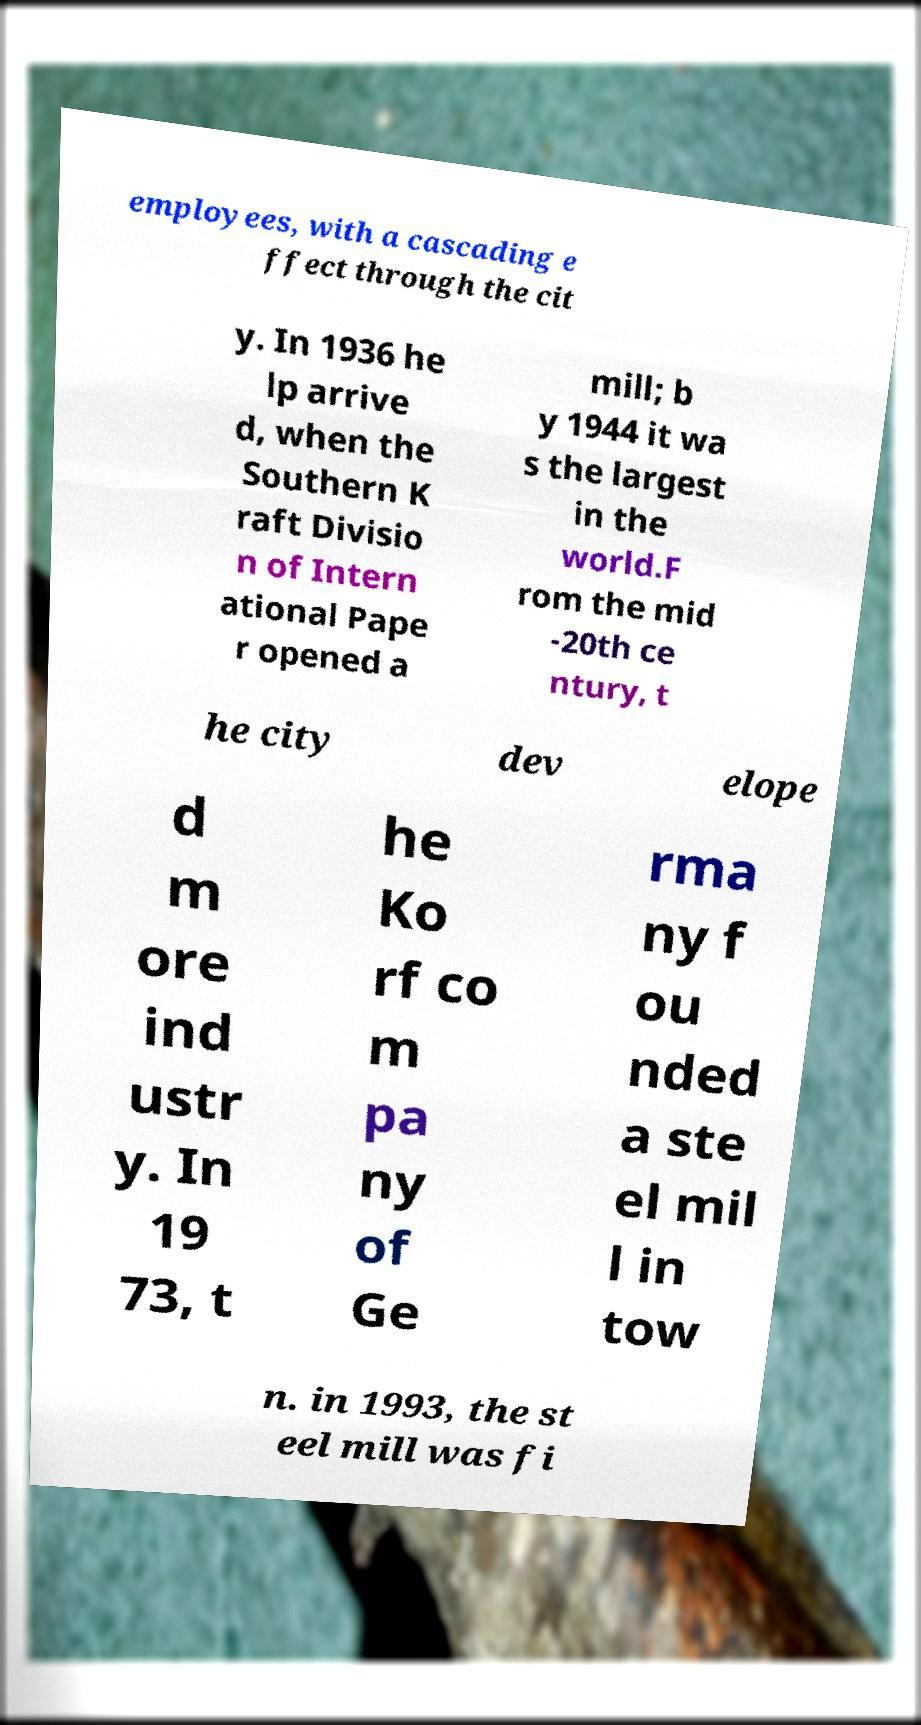Please identify and transcribe the text found in this image. employees, with a cascading e ffect through the cit y. In 1936 he lp arrive d, when the Southern K raft Divisio n of Intern ational Pape r opened a mill; b y 1944 it wa s the largest in the world.F rom the mid -20th ce ntury, t he city dev elope d m ore ind ustr y. In 19 73, t he Ko rf co m pa ny of Ge rma ny f ou nded a ste el mil l in tow n. in 1993, the st eel mill was fi 